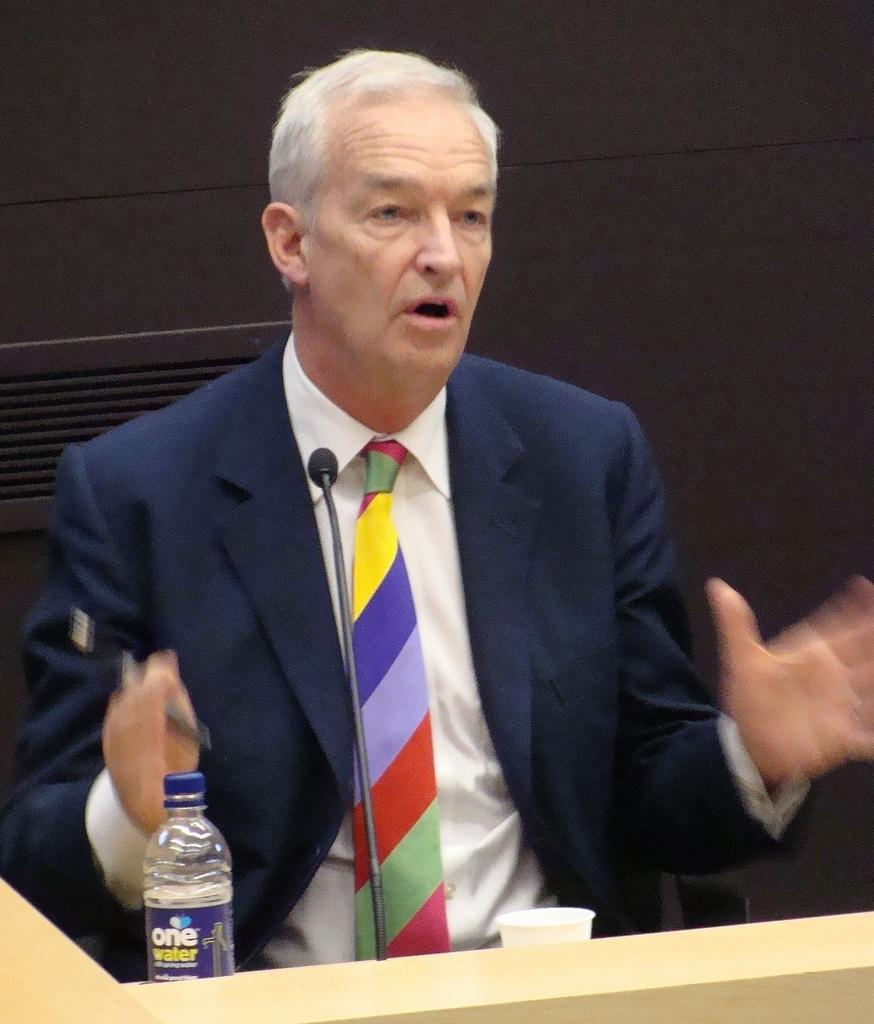What is the man in the image holding? The man is holding a microphone. What object is present near the man in the image? There is a podium in the image. What is the man doing while holding the microphone? The man is speaking while standing near the podium. What type of train can be seen passing by in the image? There is no train present in the image. What liquid is the man pouring from the microphone in the image? The man is not pouring any liquid from the microphone in the image; he is holding it to speak. What is the man using to hammer the podium in the image? The man is not using a hammer in the image; he is simply holding a microphone and speaking near the podium. 